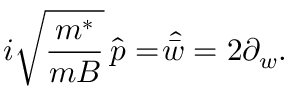Convert formula to latex. <formula><loc_0><loc_0><loc_500><loc_500>i \sqrt { \frac { m ^ { * } } { m B } } \, \widehat { p } = \widehat { \, \bar { w } } = 2 \partial _ { w } .</formula> 